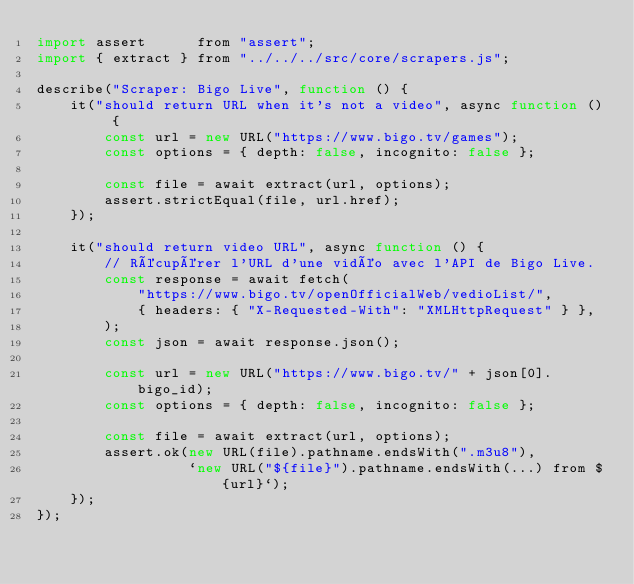Convert code to text. <code><loc_0><loc_0><loc_500><loc_500><_JavaScript_>import assert      from "assert";
import { extract } from "../../../src/core/scrapers.js";

describe("Scraper: Bigo Live", function () {
    it("should return URL when it's not a video", async function () {
        const url = new URL("https://www.bigo.tv/games");
        const options = { depth: false, incognito: false };

        const file = await extract(url, options);
        assert.strictEqual(file, url.href);
    });

    it("should return video URL", async function () {
        // Récupérer l'URL d'une vidéo avec l'API de Bigo Live.
        const response = await fetch(
            "https://www.bigo.tv/openOfficialWeb/vedioList/",
            { headers: { "X-Requested-With": "XMLHttpRequest" } },
        );
        const json = await response.json();

        const url = new URL("https://www.bigo.tv/" + json[0].bigo_id);
        const options = { depth: false, incognito: false };

        const file = await extract(url, options);
        assert.ok(new URL(file).pathname.endsWith(".m3u8"),
                  `new URL("${file}").pathname.endsWith(...) from ${url}`);
    });
});
</code> 